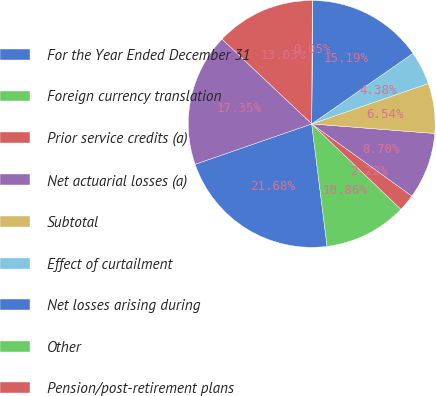Convert chart. <chart><loc_0><loc_0><loc_500><loc_500><pie_chart><fcel>For the Year Ended December 31<fcel>Foreign currency translation<fcel>Prior service credits (a)<fcel>Net actuarial losses (a)<fcel>Subtotal<fcel>Effect of curtailment<fcel>Net losses arising during<fcel>Other<fcel>Pension/post-retirement plans<fcel>Other comprehensive loss<nl><fcel>21.68%<fcel>10.86%<fcel>2.22%<fcel>8.7%<fcel>6.54%<fcel>4.38%<fcel>15.19%<fcel>0.05%<fcel>13.03%<fcel>17.35%<nl></chart> 